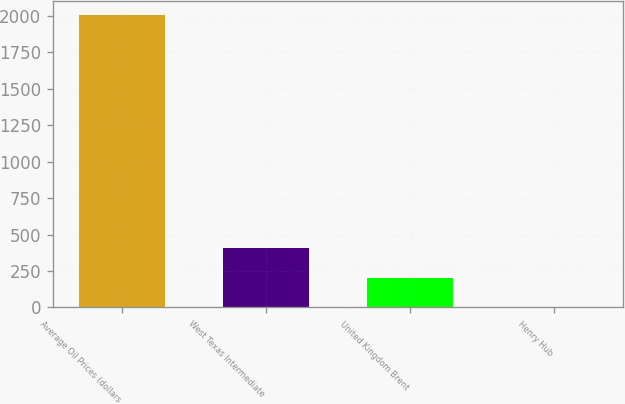Convert chart. <chart><loc_0><loc_0><loc_500><loc_500><bar_chart><fcel>Average Oil Prices (dollars<fcel>West Texas Intermediate<fcel>United Kingdom Brent<fcel>Henry Hub<nl><fcel>2003<fcel>405.11<fcel>205.37<fcel>5.63<nl></chart> 